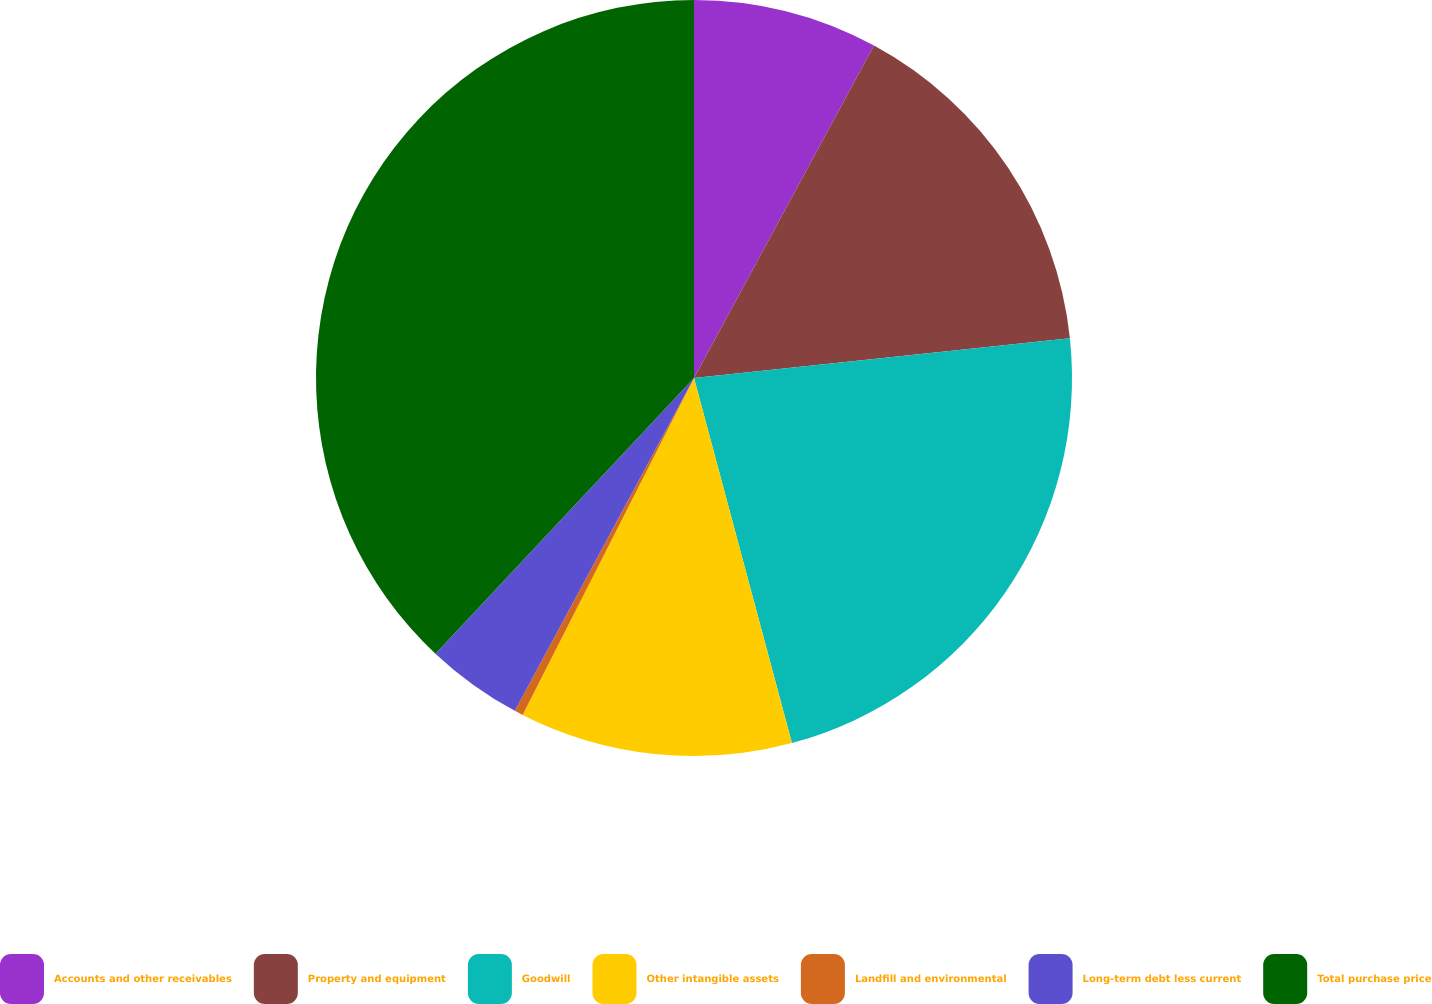Convert chart to OTSL. <chart><loc_0><loc_0><loc_500><loc_500><pie_chart><fcel>Accounts and other receivables<fcel>Property and equipment<fcel>Goodwill<fcel>Other intangible assets<fcel>Landfill and environmental<fcel>Long-term debt less current<fcel>Total purchase price<nl><fcel>7.9%<fcel>15.42%<fcel>22.51%<fcel>11.66%<fcel>0.37%<fcel>4.13%<fcel>38.01%<nl></chart> 